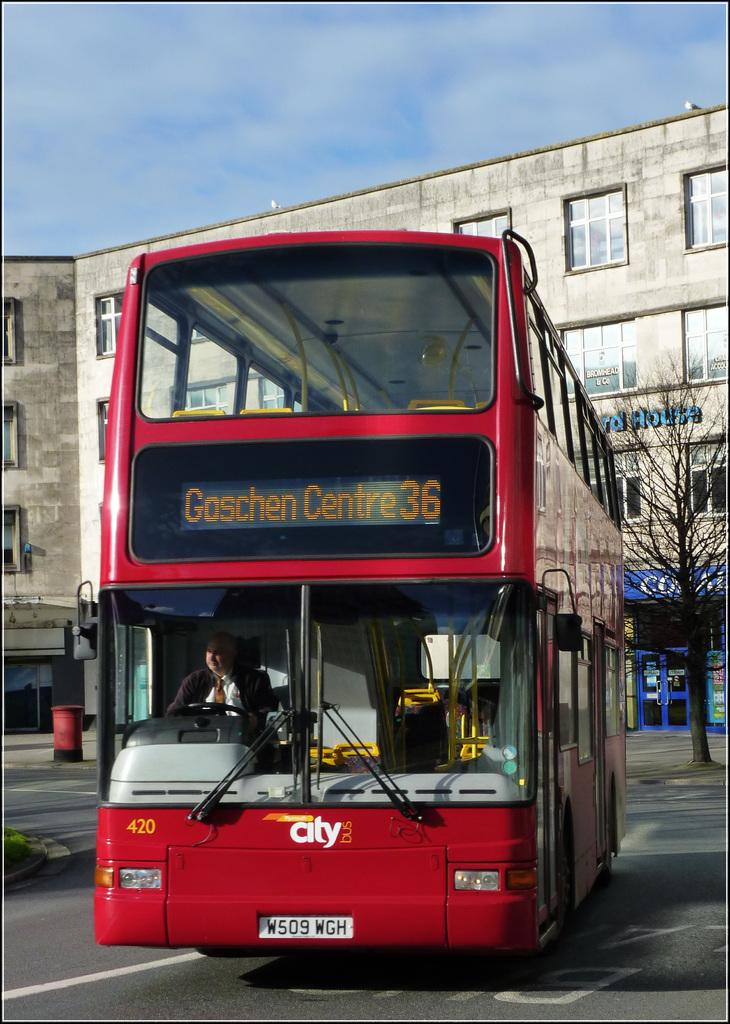<image>
Provide a brief description of the given image. A red double decker city bus is traveling to Goschen Centre. 